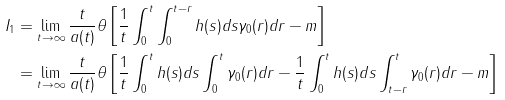<formula> <loc_0><loc_0><loc_500><loc_500>I _ { 1 } & = \lim _ { t \rightarrow \infty } \frac { t } { a ( t ) } \theta \left [ \frac { 1 } { t } \int _ { 0 } ^ { t } \int _ { 0 } ^ { t - r } h ( s ) d s \gamma _ { 0 } ( r ) d r - m \right ] \\ & = \lim _ { t \rightarrow \infty } \frac { t } { a ( t ) } \theta \left [ \frac { 1 } { t } \int _ { 0 } ^ { t } h ( s ) d s \int _ { 0 } ^ { t } \gamma _ { 0 } ( r ) d r - \frac { 1 } { t } \int _ { 0 } ^ { t } h ( s ) d s \int _ { t - r } ^ { t } \gamma _ { 0 } ( r ) d r - m \right ]</formula> 